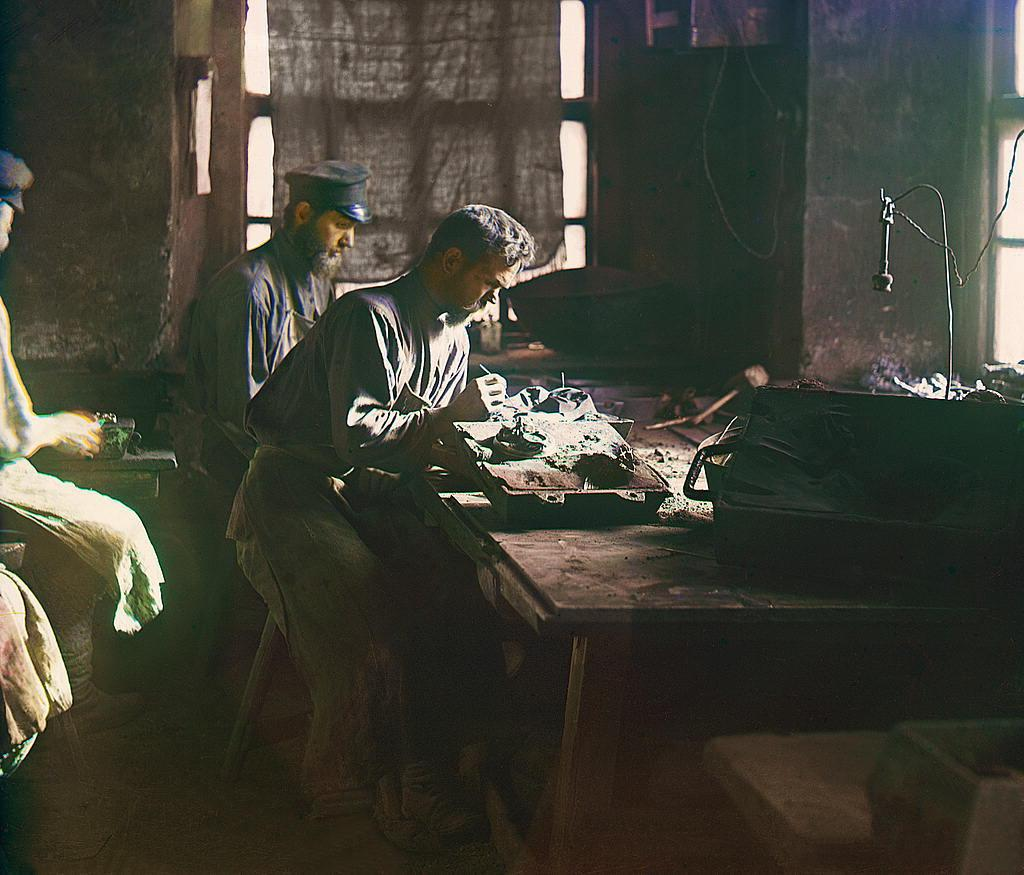How many people are in the image? There are two people in the image. What are the two people doing in the image? The two people are sitting on a table. What else is on the table besides the people? There is a bag and other objects on the table. What is the tendency of the air in the image? There is no mention of air or any tendency related to it in the image. 